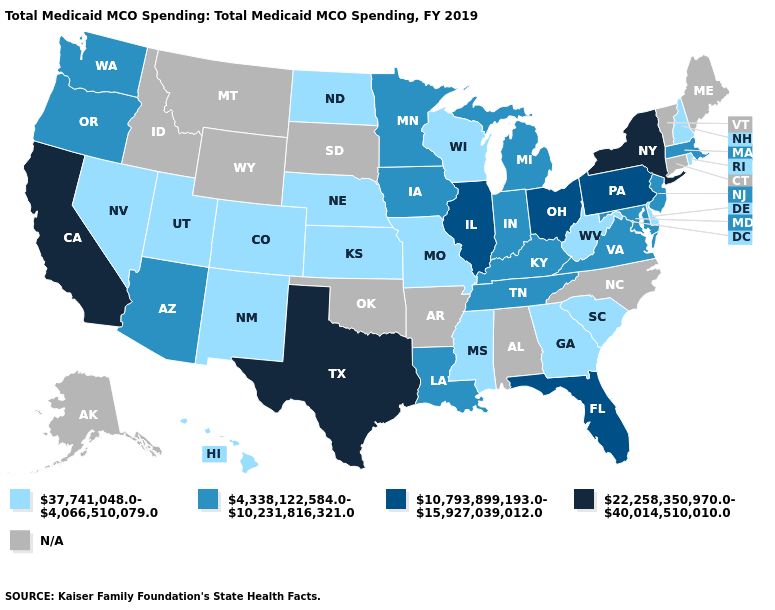What is the lowest value in states that border Arizona?
Write a very short answer. 37,741,048.0-4,066,510,079.0. Does the map have missing data?
Answer briefly. Yes. What is the lowest value in the MidWest?
Short answer required. 37,741,048.0-4,066,510,079.0. What is the lowest value in the Northeast?
Keep it brief. 37,741,048.0-4,066,510,079.0. Does the map have missing data?
Concise answer only. Yes. What is the value of Washington?
Answer briefly. 4,338,122,584.0-10,231,816,321.0. Name the states that have a value in the range 4,338,122,584.0-10,231,816,321.0?
Concise answer only. Arizona, Indiana, Iowa, Kentucky, Louisiana, Maryland, Massachusetts, Michigan, Minnesota, New Jersey, Oregon, Tennessee, Virginia, Washington. How many symbols are there in the legend?
Be succinct. 5. What is the highest value in the South ?
Short answer required. 22,258,350,970.0-40,014,510,010.0. What is the highest value in the West ?
Answer briefly. 22,258,350,970.0-40,014,510,010.0. Among the states that border Indiana , does Michigan have the highest value?
Keep it brief. No. Which states hav the highest value in the MidWest?
Keep it brief. Illinois, Ohio. Name the states that have a value in the range N/A?
Keep it brief. Alabama, Alaska, Arkansas, Connecticut, Idaho, Maine, Montana, North Carolina, Oklahoma, South Dakota, Vermont, Wyoming. Among the states that border Virginia , does West Virginia have the lowest value?
Answer briefly. Yes. 